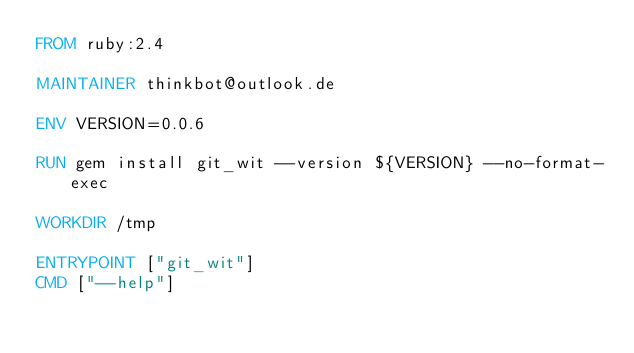Convert code to text. <code><loc_0><loc_0><loc_500><loc_500><_Dockerfile_>FROM ruby:2.4

MAINTAINER thinkbot@outlook.de

ENV VERSION=0.0.6

RUN gem install git_wit --version ${VERSION} --no-format-exec

WORKDIR /tmp

ENTRYPOINT ["git_wit"]
CMD ["--help"]
</code> 